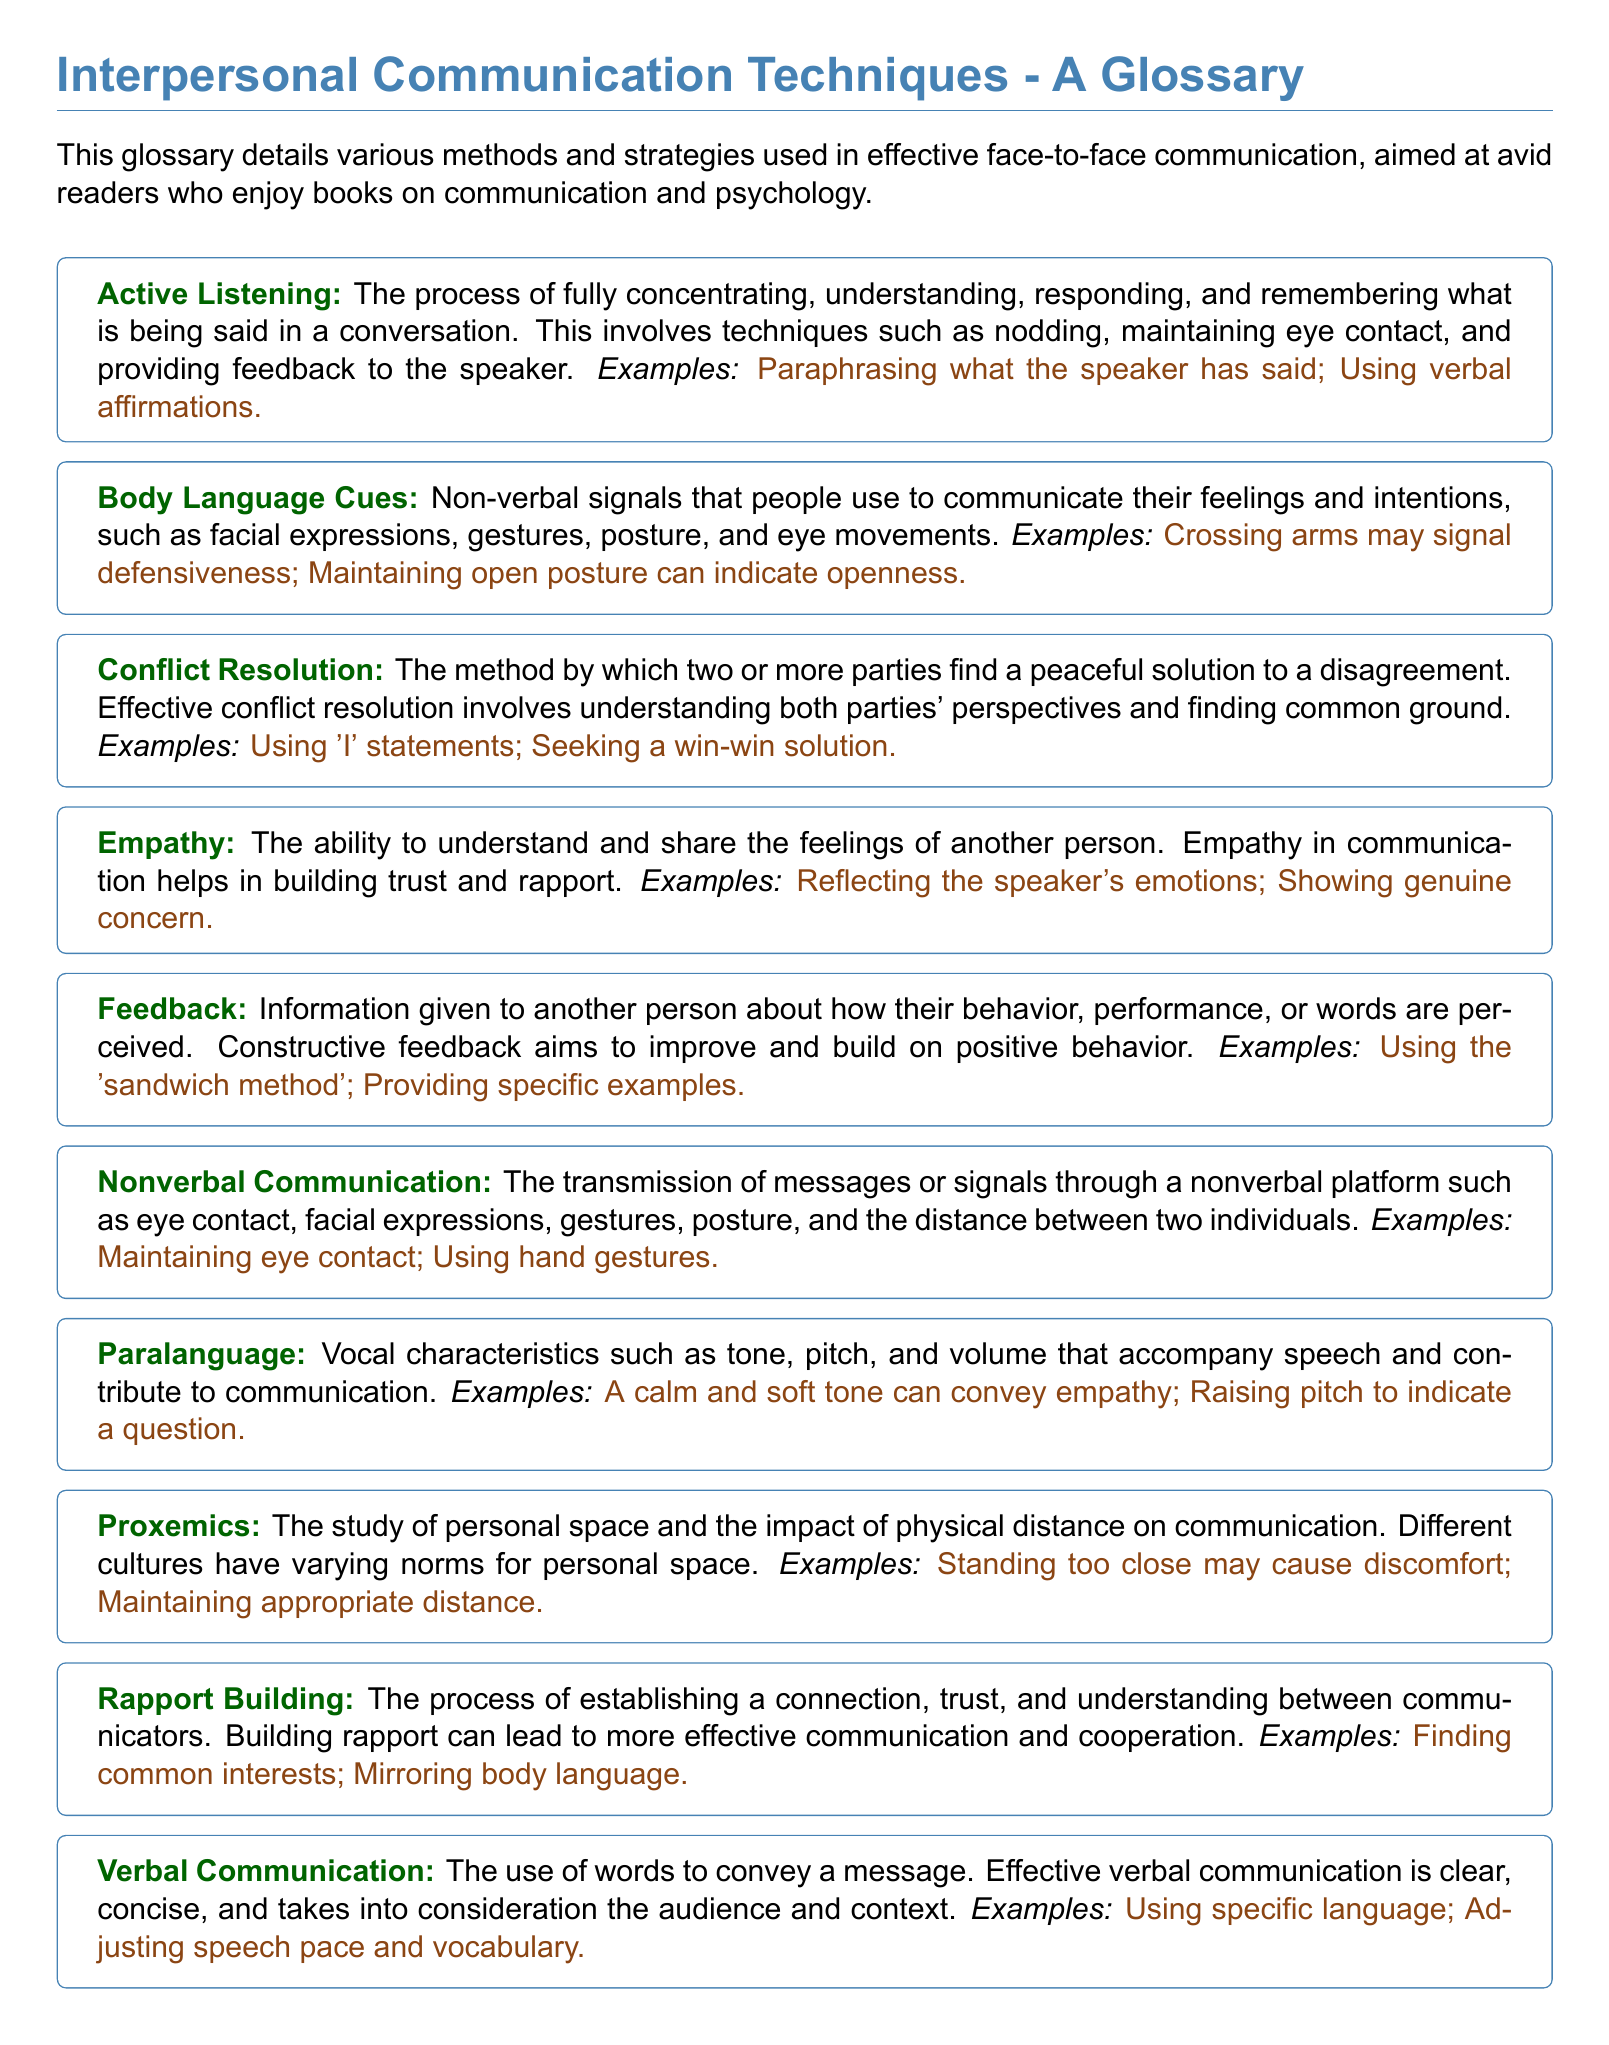What is the term for fully concentrating and responding in a conversation? The glossary defines "Active Listening" as the process of fully concentrating, understanding, responding, and remembering what is being said in a conversation.
Answer: Active Listening What involves understanding both parties' perspectives to resolve a disagreement? The term referring to this method in the glossary is "Conflict Resolution", which involves understanding both parties' perspectives and finding common ground.
Answer: Conflict Resolution What is the ability to understand and share the feelings of another person called? This is defined in the glossary as "Empathy," which is the ability to understand and share the feelings of another person.
Answer: Empathy What communication technique uses vocal characteristics like tone and pitch? The glossary mentions "Paralanguage" as the vocal characteristics that accompany speech and contribute to communication.
Answer: Paralanguage What does the glossary refer to as non-verbal signals used to express feelings? The term defined for these signals in the glossary is "Body Language Cues."
Answer: Body Language Cues Which technique involves establishing a connection and trust between communicators? The glossary defines this process as "Rapport Building," which emphasizes establishing a connection and understanding.
Answer: Rapport Building What term describes the study of personal space in communication? The glossary explains "Proxemics" as the study of personal space and its impact on communication.
Answer: Proxemics What type of communication is defined as the use of words? The glossary refers to this type of communication as "Verbal Communication."
Answer: Verbal Communication How many examples are provided for "Active Listening"? In the glossary, there are two examples provided for that term: paraphrasing and using verbal affirmations.
Answer: Two 